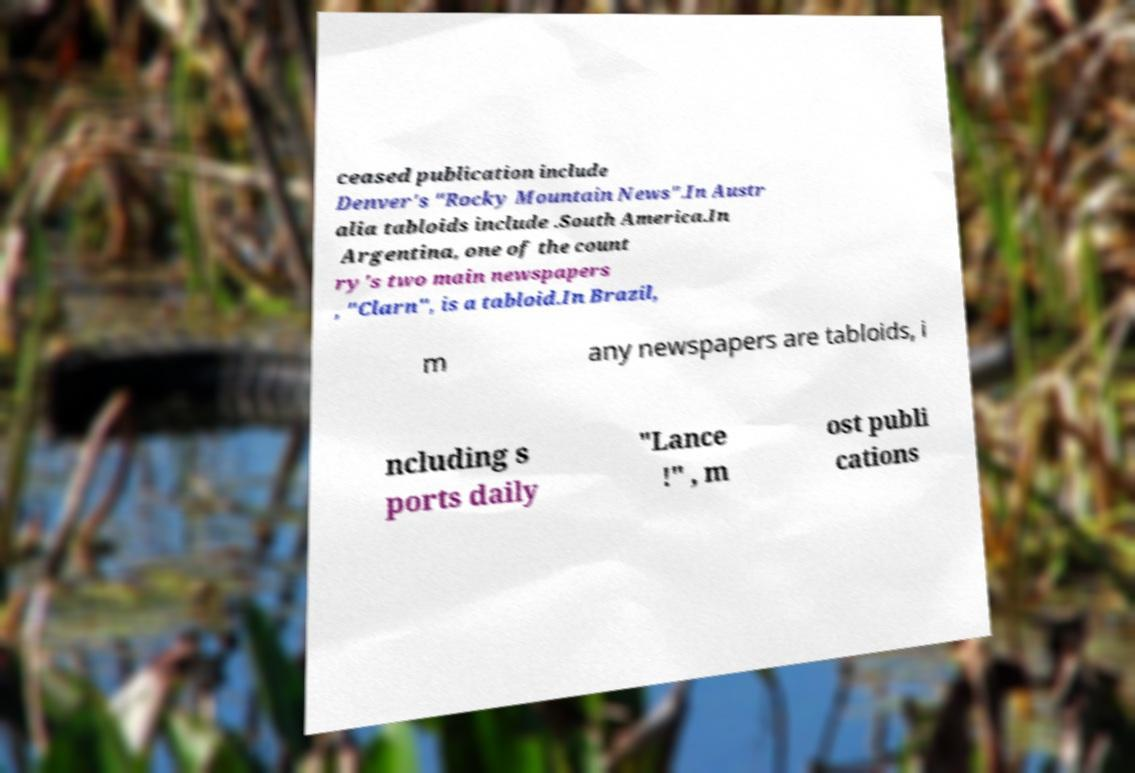I need the written content from this picture converted into text. Can you do that? ceased publication include Denver's "Rocky Mountain News".In Austr alia tabloids include .South America.In Argentina, one of the count ry's two main newspapers , "Clarn", is a tabloid.In Brazil, m any newspapers are tabloids, i ncluding s ports daily "Lance !" , m ost publi cations 